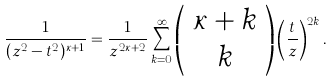<formula> <loc_0><loc_0><loc_500><loc_500>\frac { 1 } { ( z ^ { 2 } - t ^ { 2 } ) ^ { \kappa + 1 } } = \frac { 1 } { z ^ { 2 \kappa + 2 } } \sum _ { k = 0 } ^ { \infty } \left ( \begin{array} { c } \kappa + k \\ k \end{array} \right ) \left ( \frac { t } { z } \right ) ^ { 2 k } .</formula> 